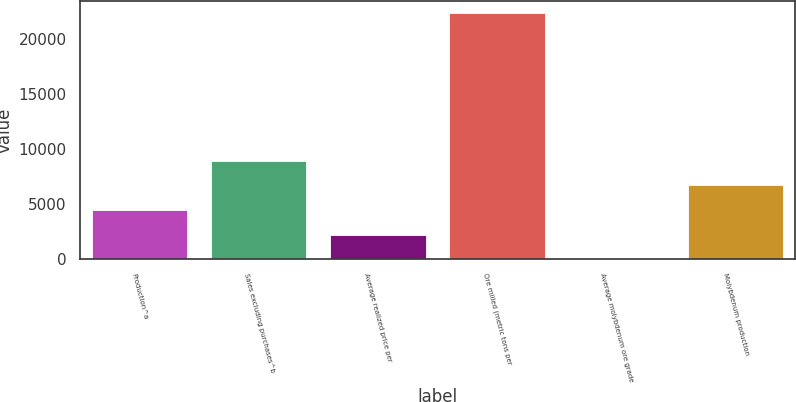Convert chart. <chart><loc_0><loc_0><loc_500><loc_500><bar_chart><fcel>Production^a<fcel>Sales excluding purchases^b<fcel>Average realized price per<fcel>Ore milled (metric tons per<fcel>Average molybdenum ore grade<fcel>Molybdenum production<nl><fcel>4460.2<fcel>8920.16<fcel>2230.22<fcel>22300<fcel>0.24<fcel>6690.18<nl></chart> 